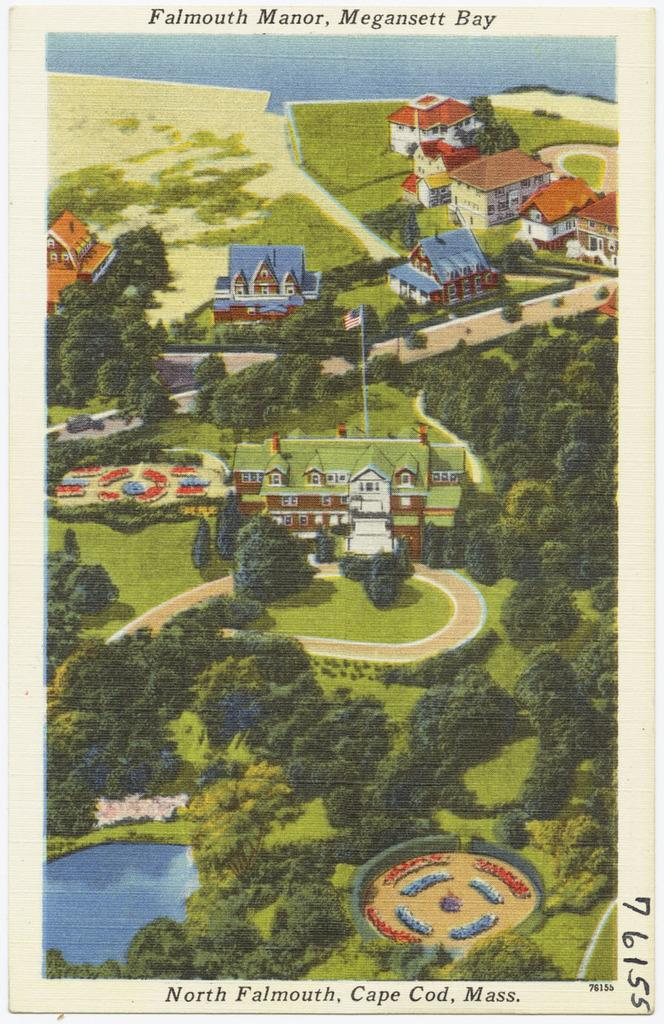<image>
Give a short and clear explanation of the subsequent image. A card displays an aerial view of Falmouth Manor. 